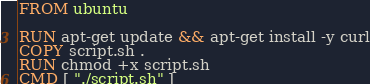Convert code to text. <code><loc_0><loc_0><loc_500><loc_500><_Dockerfile_>FROM ubuntu

RUN apt-get update && apt-get install -y curl
COPY script.sh .
RUN chmod +x script.sh
CMD [ "./script.sh" ]</code> 